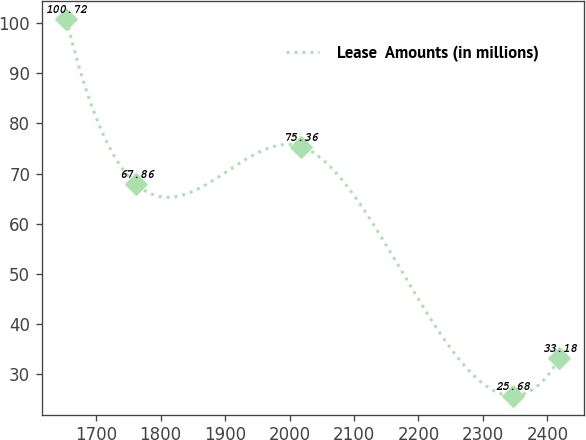<chart> <loc_0><loc_0><loc_500><loc_500><line_chart><ecel><fcel>Lease  Amounts (in millions)<nl><fcel>1653.88<fcel>100.72<nl><fcel>1762.17<fcel>67.86<nl><fcel>2018.06<fcel>75.36<nl><fcel>2346.31<fcel>25.68<nl><fcel>2418.69<fcel>33.18<nl></chart> 